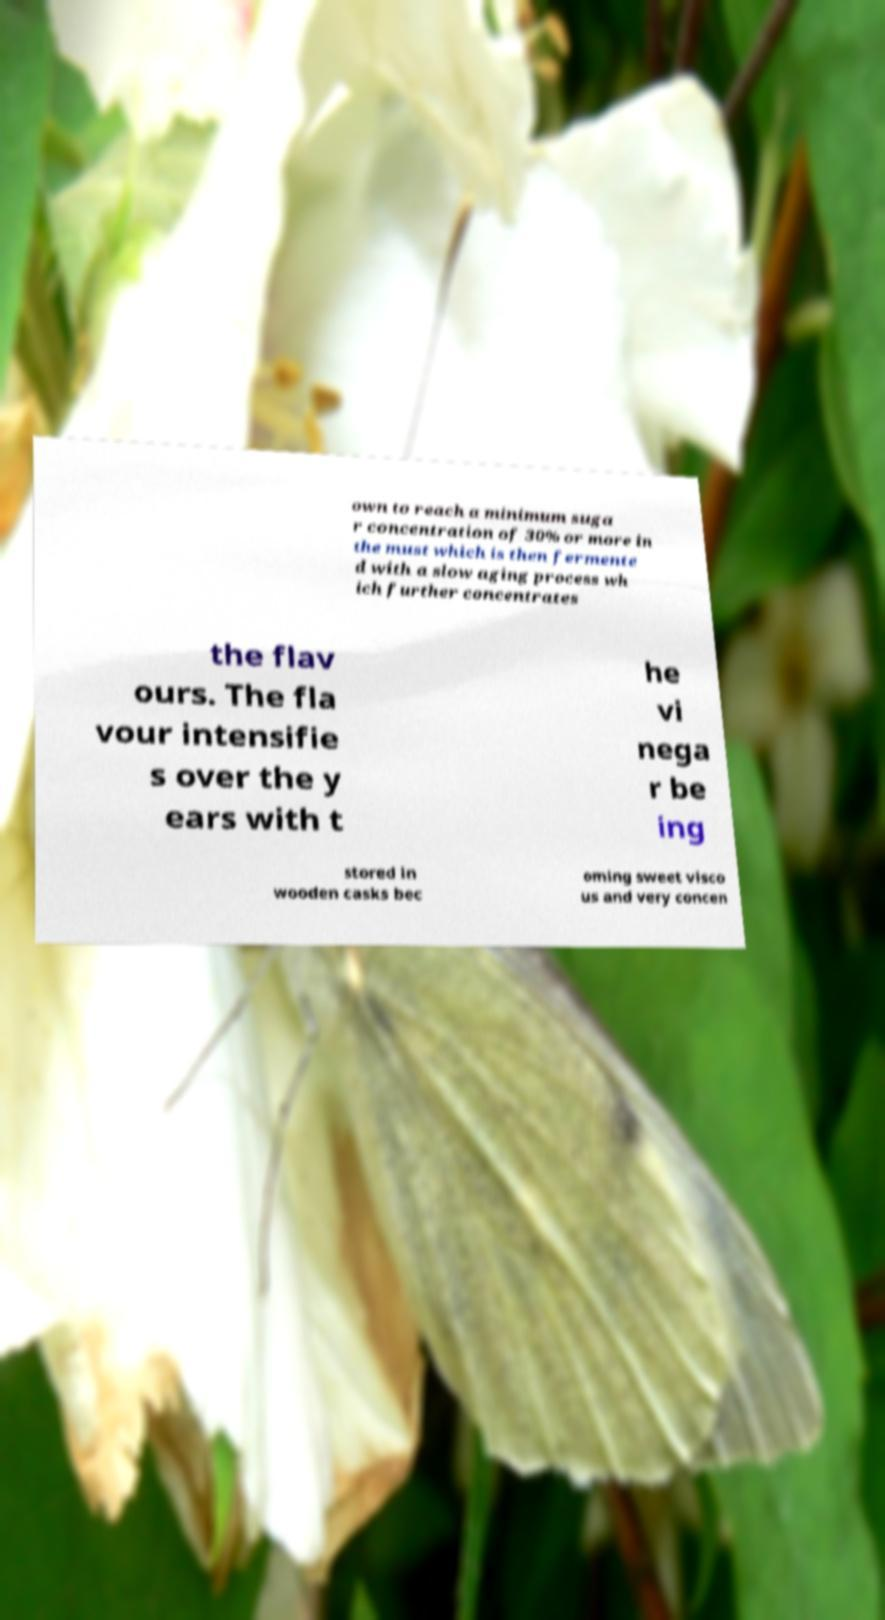Please read and relay the text visible in this image. What does it say? own to reach a minimum suga r concentration of 30% or more in the must which is then fermente d with a slow aging process wh ich further concentrates the flav ours. The fla vour intensifie s over the y ears with t he vi nega r be ing stored in wooden casks bec oming sweet visco us and very concen 